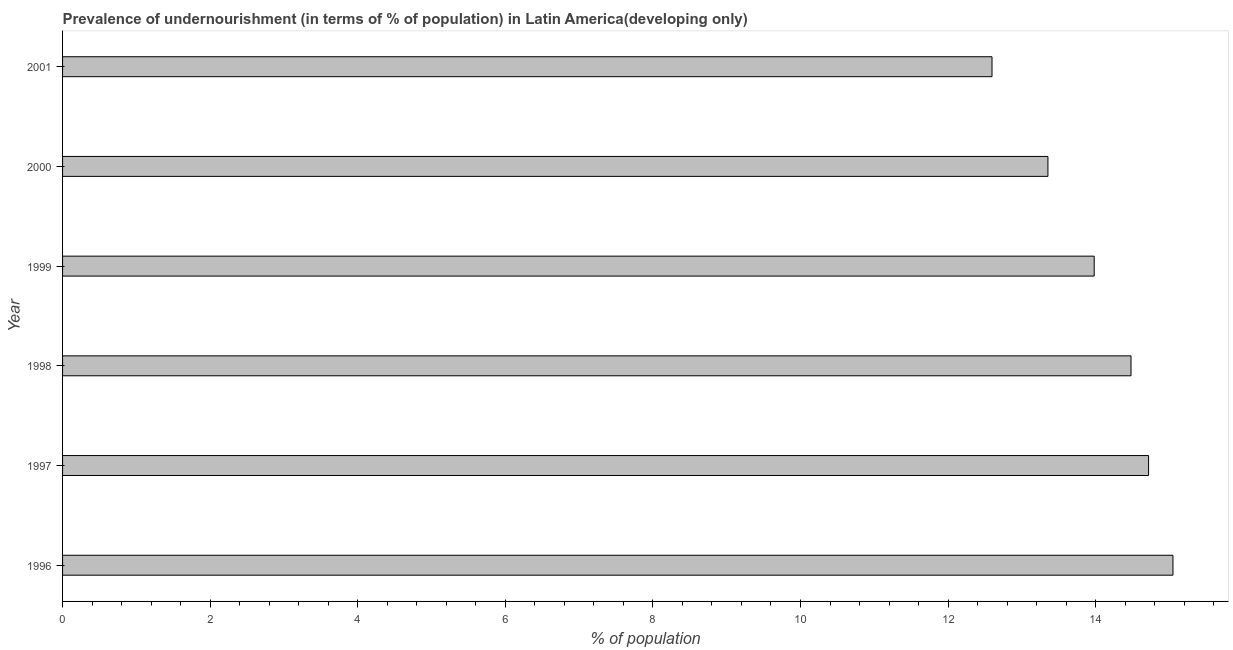What is the title of the graph?
Provide a succinct answer. Prevalence of undernourishment (in terms of % of population) in Latin America(developing only). What is the label or title of the X-axis?
Keep it short and to the point. % of population. What is the percentage of undernourished population in 2000?
Make the answer very short. 13.35. Across all years, what is the maximum percentage of undernourished population?
Offer a very short reply. 15.05. Across all years, what is the minimum percentage of undernourished population?
Ensure brevity in your answer.  12.6. In which year was the percentage of undernourished population maximum?
Provide a short and direct response. 1996. What is the sum of the percentage of undernourished population?
Ensure brevity in your answer.  84.17. What is the difference between the percentage of undernourished population in 1996 and 2000?
Offer a very short reply. 1.69. What is the average percentage of undernourished population per year?
Keep it short and to the point. 14.03. What is the median percentage of undernourished population?
Offer a terse response. 14.23. Do a majority of the years between 2001 and 1996 (inclusive) have percentage of undernourished population greater than 8.8 %?
Ensure brevity in your answer.  Yes. What is the ratio of the percentage of undernourished population in 1998 to that in 2001?
Make the answer very short. 1.15. Is the percentage of undernourished population in 1996 less than that in 1998?
Provide a succinct answer. No. Is the difference between the percentage of undernourished population in 1999 and 2001 greater than the difference between any two years?
Offer a terse response. No. What is the difference between the highest and the second highest percentage of undernourished population?
Your answer should be very brief. 0.33. Is the sum of the percentage of undernourished population in 1996 and 2001 greater than the maximum percentage of undernourished population across all years?
Offer a terse response. Yes. What is the difference between the highest and the lowest percentage of undernourished population?
Make the answer very short. 2.45. How many bars are there?
Your answer should be very brief. 6. What is the % of population in 1996?
Make the answer very short. 15.05. What is the % of population of 1997?
Your answer should be compact. 14.72. What is the % of population of 1998?
Your answer should be compact. 14.48. What is the % of population of 1999?
Your answer should be compact. 13.98. What is the % of population of 2000?
Offer a terse response. 13.35. What is the % of population in 2001?
Provide a succinct answer. 12.6. What is the difference between the % of population in 1996 and 1997?
Offer a terse response. 0.33. What is the difference between the % of population in 1996 and 1998?
Your response must be concise. 0.57. What is the difference between the % of population in 1996 and 1999?
Ensure brevity in your answer.  1.07. What is the difference between the % of population in 1996 and 2000?
Provide a succinct answer. 1.69. What is the difference between the % of population in 1996 and 2001?
Give a very brief answer. 2.45. What is the difference between the % of population in 1997 and 1998?
Make the answer very short. 0.24. What is the difference between the % of population in 1997 and 1999?
Your answer should be compact. 0.74. What is the difference between the % of population in 1997 and 2000?
Provide a succinct answer. 1.36. What is the difference between the % of population in 1997 and 2001?
Provide a succinct answer. 2.12. What is the difference between the % of population in 1998 and 1999?
Provide a succinct answer. 0.5. What is the difference between the % of population in 1998 and 2000?
Keep it short and to the point. 1.13. What is the difference between the % of population in 1998 and 2001?
Your response must be concise. 1.88. What is the difference between the % of population in 1999 and 2000?
Your answer should be very brief. 0.63. What is the difference between the % of population in 1999 and 2001?
Your answer should be compact. 1.38. What is the difference between the % of population in 2000 and 2001?
Your answer should be very brief. 0.76. What is the ratio of the % of population in 1996 to that in 1998?
Your answer should be very brief. 1.04. What is the ratio of the % of population in 1996 to that in 1999?
Your answer should be very brief. 1.08. What is the ratio of the % of population in 1996 to that in 2000?
Keep it short and to the point. 1.13. What is the ratio of the % of population in 1996 to that in 2001?
Give a very brief answer. 1.2. What is the ratio of the % of population in 1997 to that in 1998?
Keep it short and to the point. 1.02. What is the ratio of the % of population in 1997 to that in 1999?
Your answer should be very brief. 1.05. What is the ratio of the % of population in 1997 to that in 2000?
Make the answer very short. 1.1. What is the ratio of the % of population in 1997 to that in 2001?
Your response must be concise. 1.17. What is the ratio of the % of population in 1998 to that in 1999?
Offer a terse response. 1.04. What is the ratio of the % of population in 1998 to that in 2000?
Give a very brief answer. 1.08. What is the ratio of the % of population in 1998 to that in 2001?
Provide a short and direct response. 1.15. What is the ratio of the % of population in 1999 to that in 2000?
Keep it short and to the point. 1.05. What is the ratio of the % of population in 1999 to that in 2001?
Your answer should be compact. 1.11. What is the ratio of the % of population in 2000 to that in 2001?
Your answer should be compact. 1.06. 